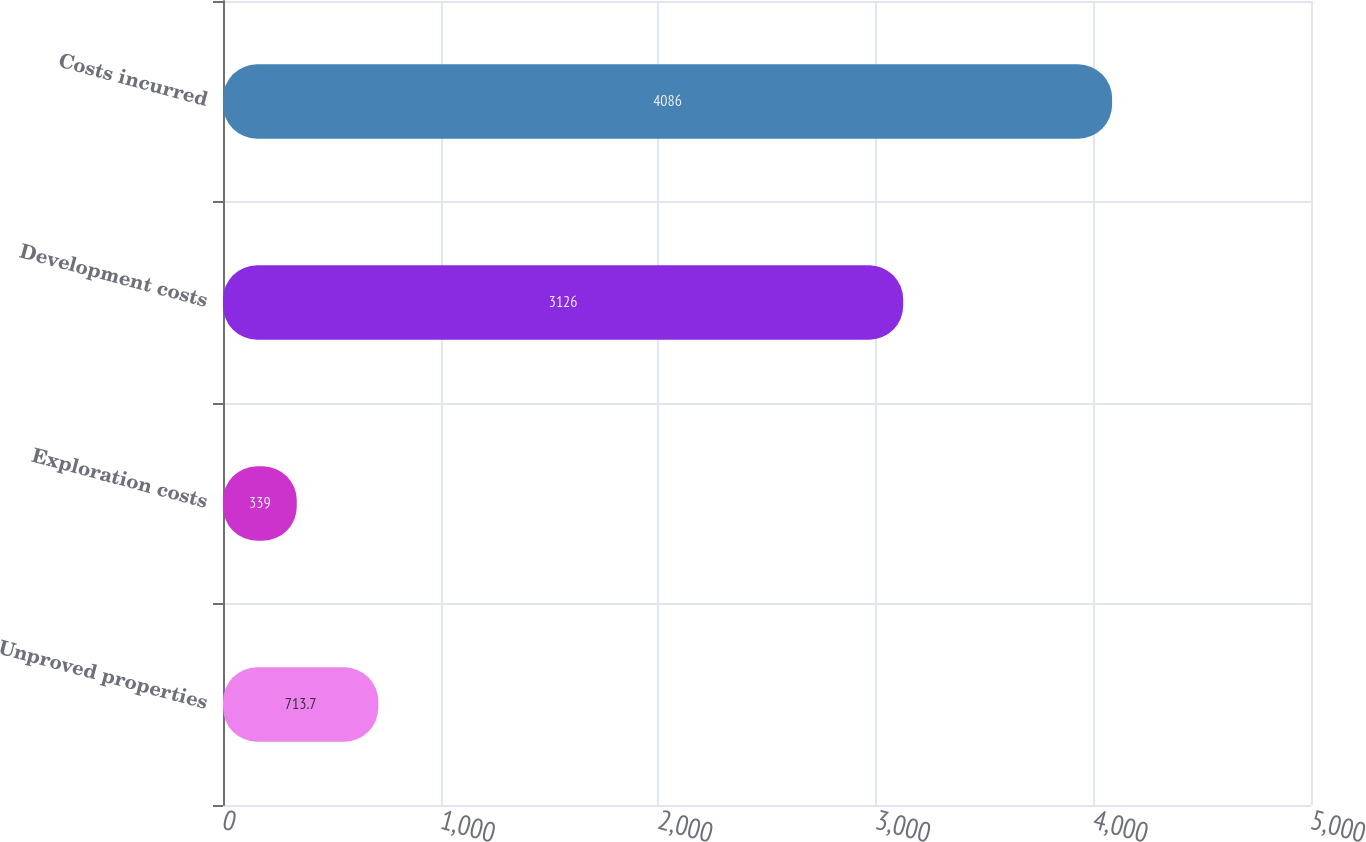<chart> <loc_0><loc_0><loc_500><loc_500><bar_chart><fcel>Unproved properties<fcel>Exploration costs<fcel>Development costs<fcel>Costs incurred<nl><fcel>713.7<fcel>339<fcel>3126<fcel>4086<nl></chart> 